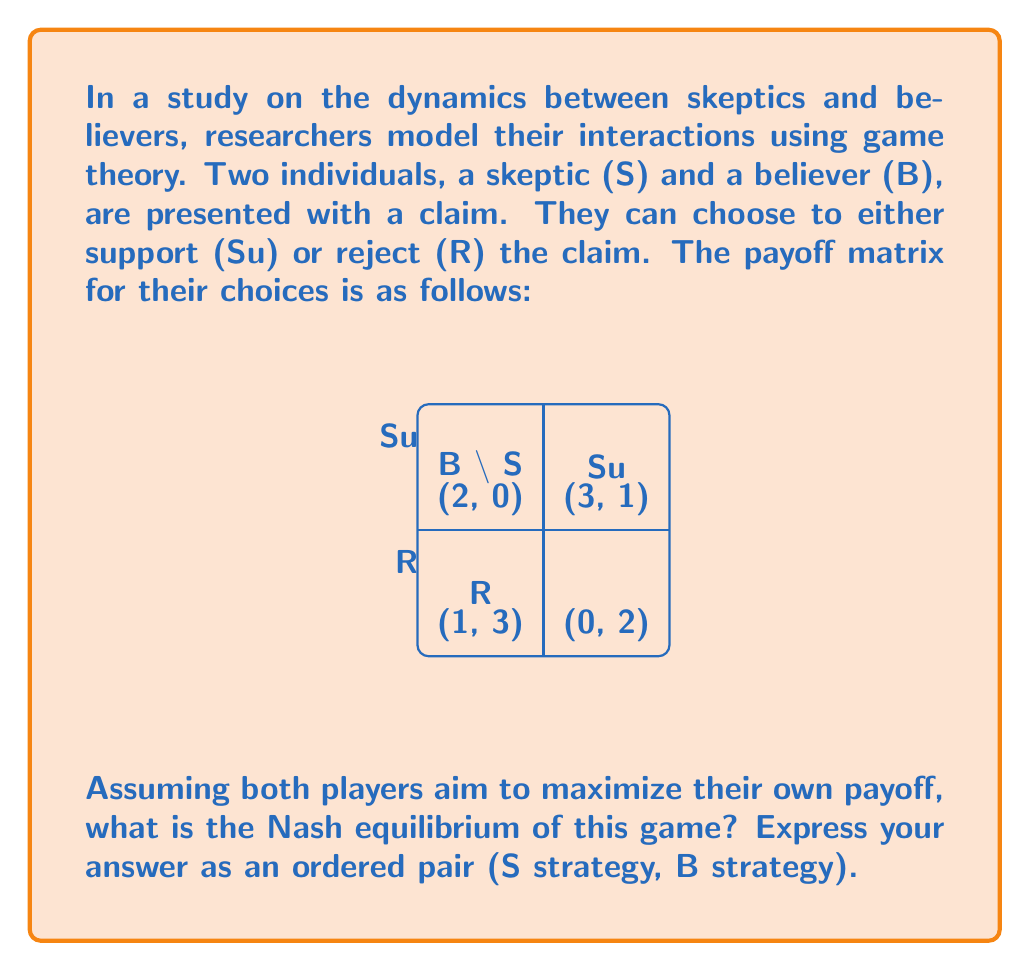Solve this math problem. To find the Nash equilibrium, we need to analyze each player's best response to the other player's strategy:

1. Skeptic's perspective:
   - If B chooses Su, S gets 1 for Su and 2 for R. Best response: R
   - If B chooses R, S gets 0 for Su and 3 for R. Best response: R

2. Believer's perspective:
   - If S chooses Su, B gets 3 for Su and 2 for R. Best response: Su
   - If S chooses R, B gets 1 for Su and 3 for R. Best response: R

3. Nash equilibrium occurs when both players are playing their best response to the other's strategy.

4. From the analysis:
   - S will always choose R (dominant strategy)
   - B's best response to S choosing R is R

5. Therefore, the Nash equilibrium is (R, R), where both the skeptic and believer reject the claim.

This outcome reflects a situation where skepticism prevails, even for the believer, when faced with a skeptical opponent. Psychologically, this could represent how social influence and the fear of being wrong can affect belief systems in interpersonal interactions.
Answer: (R, R) 